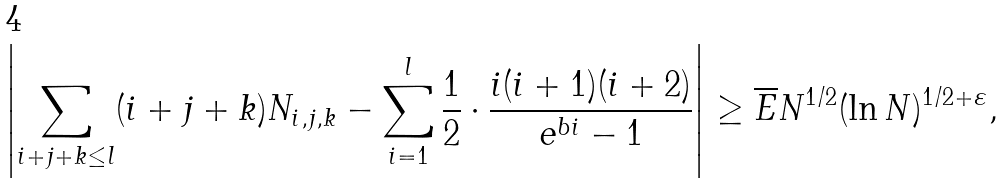<formula> <loc_0><loc_0><loc_500><loc_500>\left | \sum _ { i + j + k \leq l } ( i + j + k ) N _ { i , j , k } - \sum ^ { l } _ { i = 1 } \frac { 1 } { 2 } \cdot \frac { i ( i + 1 ) ( i + 2 ) } { e ^ { b i } - 1 } \right | \geq \overline { E } N ^ { 1 / 2 } ( \ln N ) ^ { 1 / 2 + \varepsilon } ,</formula> 